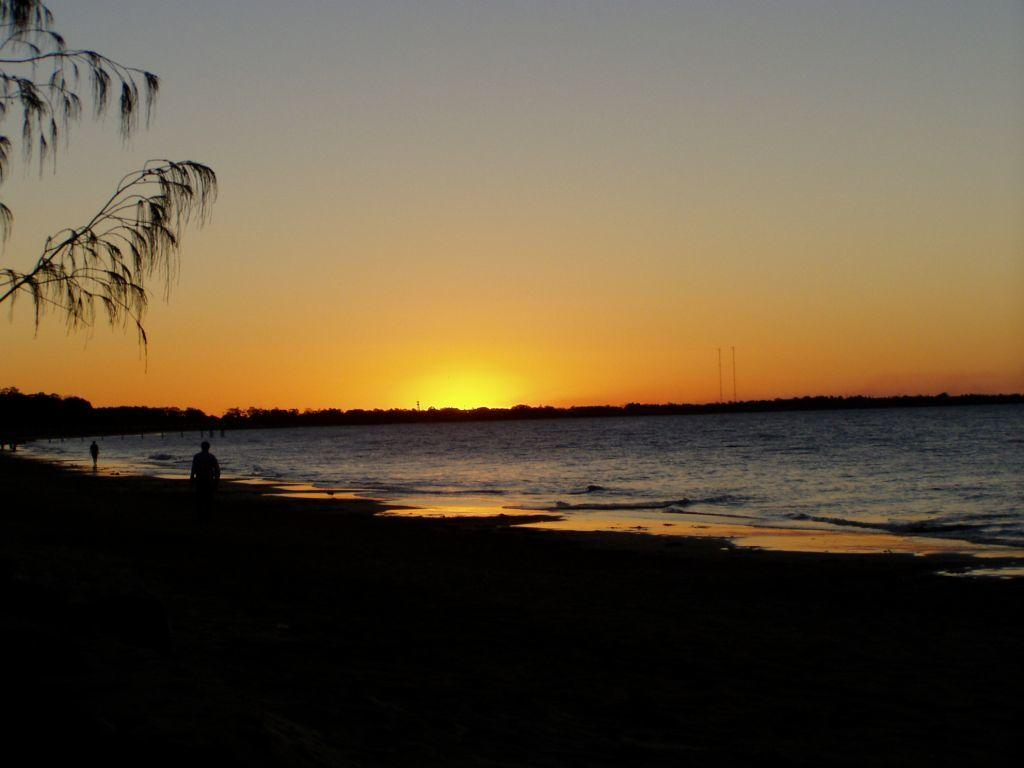Who or what can be seen in the front of the image? There are persons in the front of the image. What can be seen in the distance behind the persons? There are trees in the background of the image. What is located in the center of the image? There is water in the center of the image. What type of silk is being used by the manager in the image? There is no manager or silk present in the image. How does the balance of the persons in the image affect their posture? The provided facts do not mention the balance or posture of the persons in the image. 